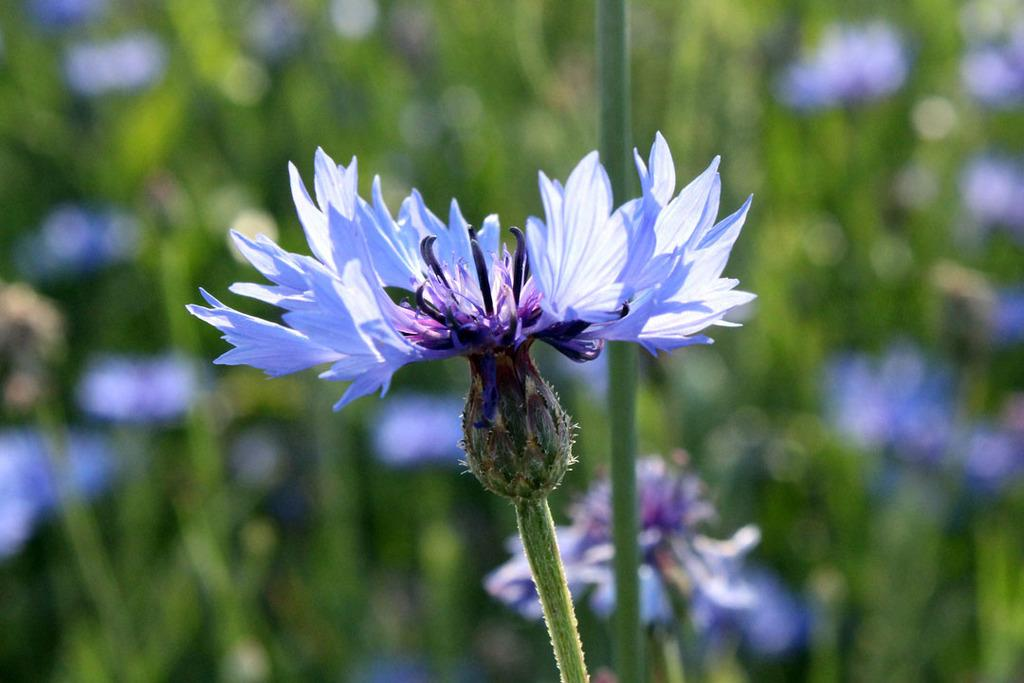What is the main subject in the center of the image? There are flowers in the center of the image. How would you describe the background of the image? The background of the image is blurry. What other parts of plants can be seen in the image besides flowers? Leaves of plants are visible in the image. Can you describe the flowers that are visible in the image? Flowers of plants are visible in the image. What type of yarn is being used to create the flowers in the image? There is no yarn present in the image; the flowers are real flowers. Is there a mailbox visible in the image? No, there is no mailbox present in the image. 